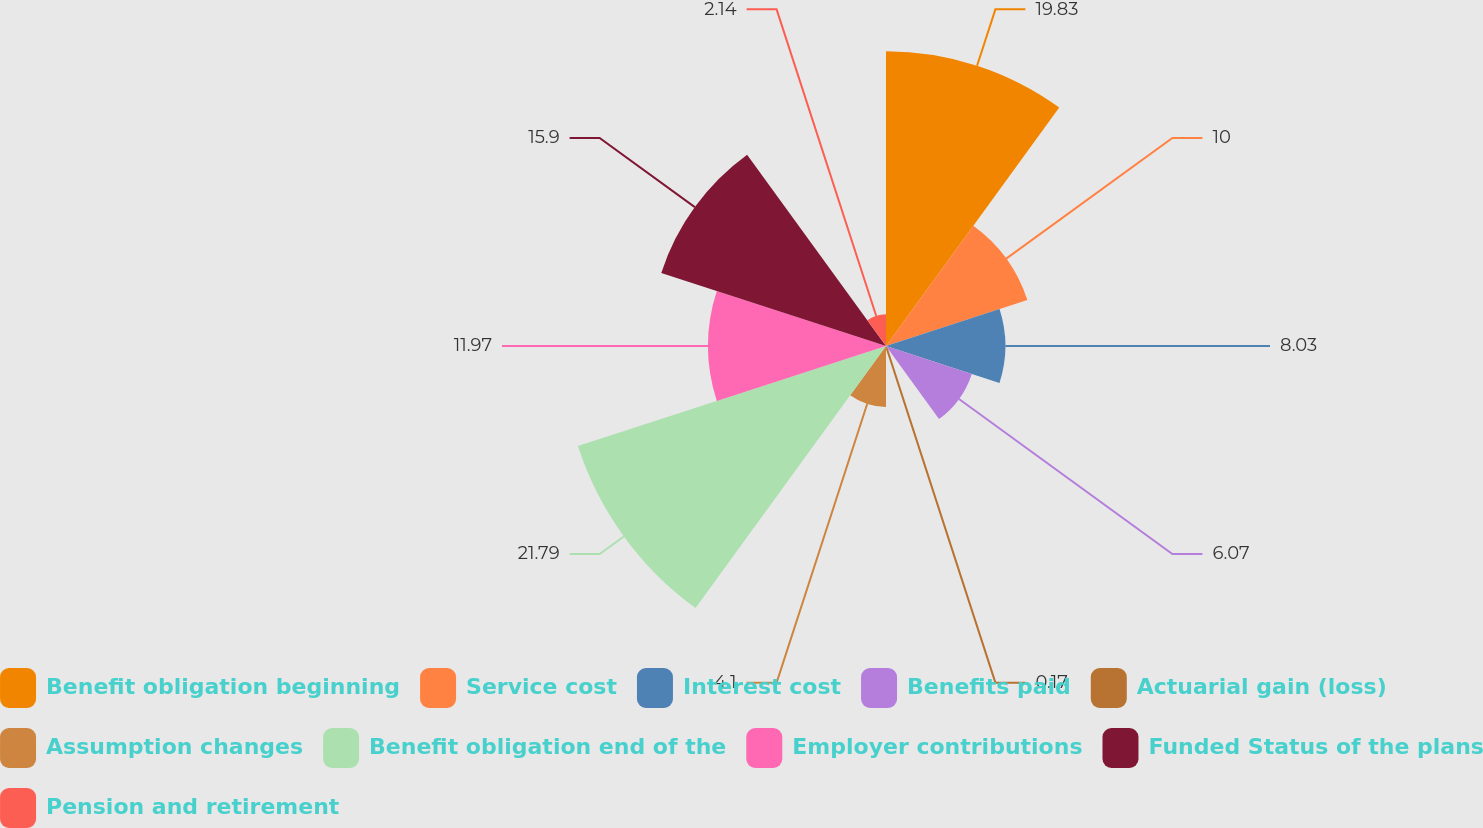<chart> <loc_0><loc_0><loc_500><loc_500><pie_chart><fcel>Benefit obligation beginning<fcel>Service cost<fcel>Interest cost<fcel>Benefits paid<fcel>Actuarial gain (loss)<fcel>Assumption changes<fcel>Benefit obligation end of the<fcel>Employer contributions<fcel>Funded Status of the plans<fcel>Pension and retirement<nl><fcel>19.83%<fcel>10.0%<fcel>8.03%<fcel>6.07%<fcel>0.17%<fcel>4.1%<fcel>21.8%<fcel>11.97%<fcel>15.9%<fcel>2.14%<nl></chart> 